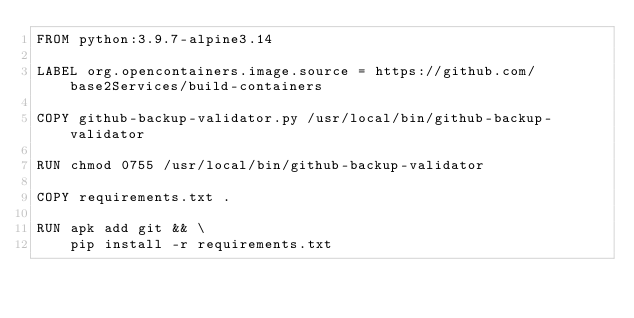<code> <loc_0><loc_0><loc_500><loc_500><_Dockerfile_>FROM python:3.9.7-alpine3.14

LABEL org.opencontainers.image.source = https://github.com/base2Services/build-containers

COPY github-backup-validator.py /usr/local/bin/github-backup-validator

RUN chmod 0755 /usr/local/bin/github-backup-validator

COPY requirements.txt .

RUN apk add git && \
    pip install -r requirements.txt
</code> 